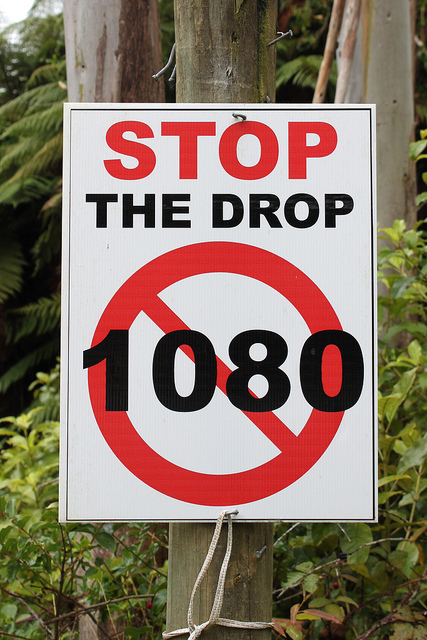Extract all visible text content from this image. STOP THE DROP 1080 